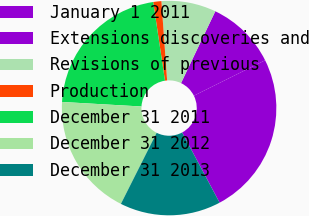Convert chart. <chart><loc_0><loc_0><loc_500><loc_500><pie_chart><fcel>January 1 2011<fcel>Extensions discoveries and<fcel>Revisions of previous<fcel>Production<fcel>December 31 2011<fcel>December 31 2012<fcel>December 31 2013<nl><fcel>24.55%<fcel>10.56%<fcel>8.23%<fcel>1.23%<fcel>21.72%<fcel>18.49%<fcel>15.22%<nl></chart> 